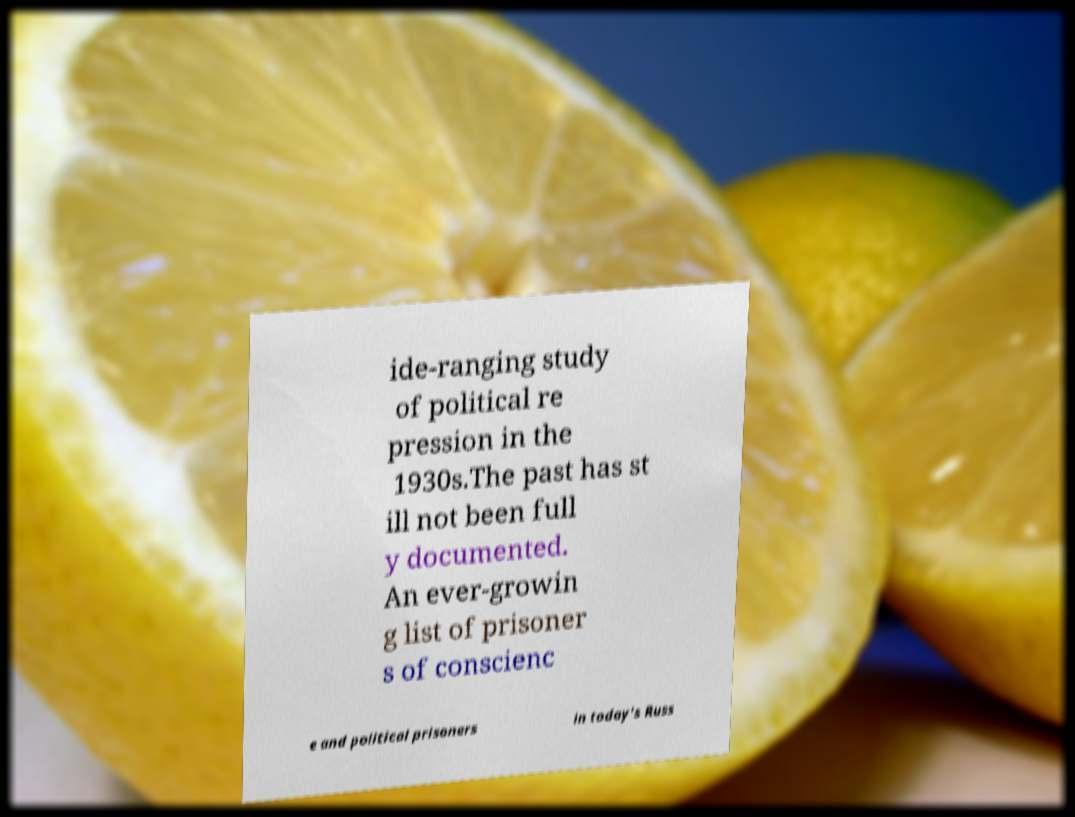What messages or text are displayed in this image? I need them in a readable, typed format. ide-ranging study of political re pression in the 1930s.The past has st ill not been full y documented. An ever-growin g list of prisoner s of conscienc e and political prisoners in today's Russ 